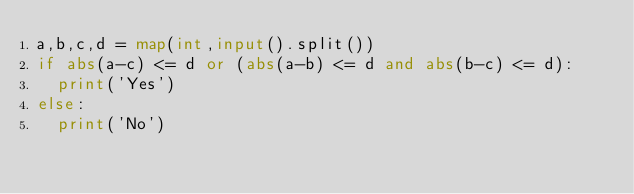Convert code to text. <code><loc_0><loc_0><loc_500><loc_500><_Python_>a,b,c,d = map(int,input().split())
if abs(a-c) <= d or (abs(a-b) <= d and abs(b-c) <= d):
  print('Yes')
else:
  print('No')
</code> 